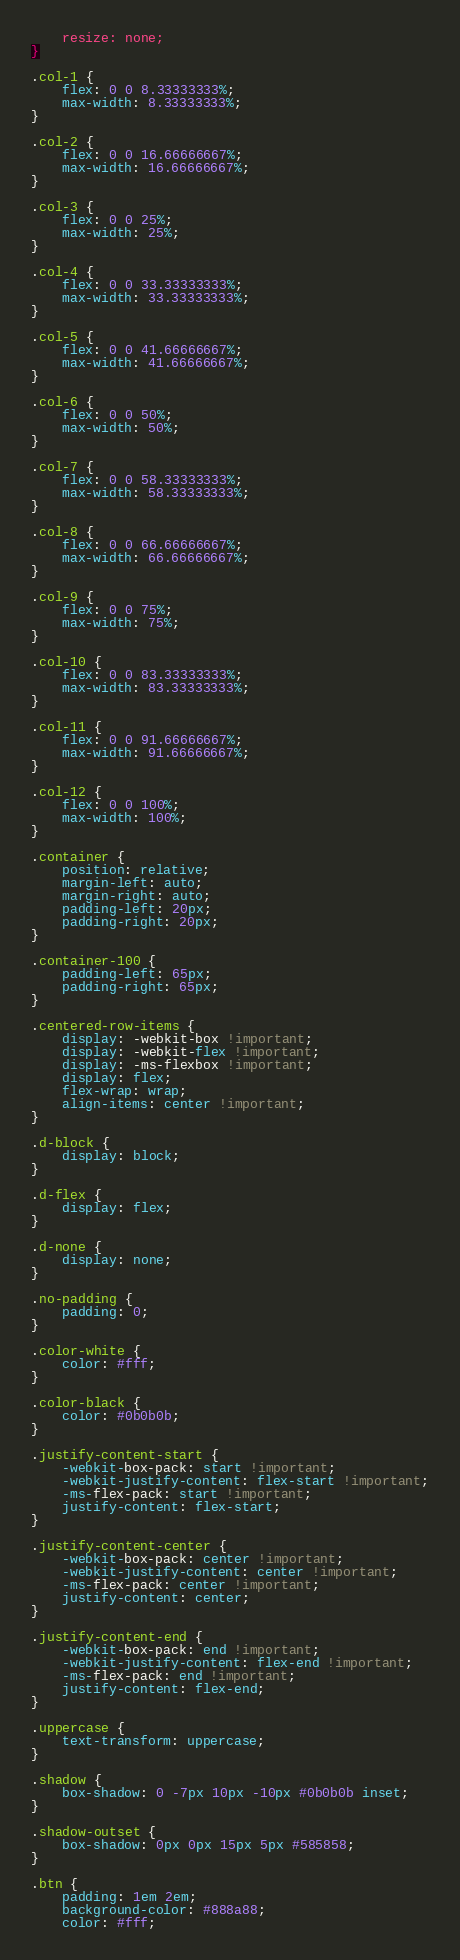Convert code to text. <code><loc_0><loc_0><loc_500><loc_500><_CSS_>    resize: none;
}

.col-1 {
    flex: 0 0 8.33333333%;
    max-width: 8.33333333%;
}

.col-2 {
    flex: 0 0 16.66666667%;
    max-width: 16.66666667%;
}

.col-3 {
    flex: 0 0 25%;
    max-width: 25%;
}

.col-4 {
    flex: 0 0 33.33333333%;
    max-width: 33.33333333%;
}

.col-5 {
    flex: 0 0 41.66666667%;
    max-width: 41.66666667%;
}

.col-6 {
    flex: 0 0 50%;
    max-width: 50%;
}

.col-7 {
    flex: 0 0 58.33333333%;
    max-width: 58.33333333%;
}

.col-8 {
    flex: 0 0 66.66666667%;
    max-width: 66.66666667%;
}

.col-9 {
    flex: 0 0 75%;
    max-width: 75%;
}

.col-10 {
    flex: 0 0 83.33333333%;
    max-width: 83.33333333%;
}

.col-11 {
    flex: 0 0 91.66666667%;
    max-width: 91.66666667%;
}

.col-12 {
    flex: 0 0 100%;
    max-width: 100%;
}

.container {
    position: relative;
    margin-left: auto;
    margin-right: auto;
    padding-left: 20px;
    padding-right: 20px;
}

.container-100 {
    padding-left: 65px;
    padding-right: 65px;
}

.centered-row-items {
    display: -webkit-box !important;
    display: -webkit-flex !important;
    display: -ms-flexbox !important;
    display: flex;
    flex-wrap: wrap;
    align-items: center !important;
}

.d-block {
    display: block;
}

.d-flex {
    display: flex;
}

.d-none {
    display: none;
}

.no-padding {
    padding: 0;
}

.color-white {
    color: #fff;
}

.color-black {
    color: #0b0b0b;
}

.justify-content-start {
    -webkit-box-pack: start !important;
    -webkit-justify-content: flex-start !important;
    -ms-flex-pack: start !important;
    justify-content: flex-start;
}

.justify-content-center {
    -webkit-box-pack: center !important;
    -webkit-justify-content: center !important;
    -ms-flex-pack: center !important;
    justify-content: center;
}

.justify-content-end {
    -webkit-box-pack: end !important;
    -webkit-justify-content: flex-end !important;
    -ms-flex-pack: end !important;
    justify-content: flex-end;
}

.uppercase {
    text-transform: uppercase;
}

.shadow {
    box-shadow: 0 -7px 10px -10px #0b0b0b inset;
}

.shadow-outset {
    box-shadow: 0px 0px 15px 5px #585858;
}

.btn {
    padding: 1em 2em;
    background-color: #888a88;
    color: #fff;</code> 